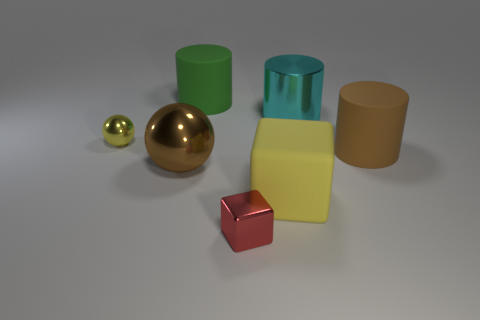What color is the thing that is both in front of the brown metallic ball and left of the big yellow thing?
Give a very brief answer. Red. Is there a small blue rubber thing of the same shape as the yellow metal thing?
Provide a short and direct response. No. What is the material of the big cyan cylinder?
Give a very brief answer. Metal. There is a yellow metallic object; are there any large cyan objects in front of it?
Your answer should be very brief. No. Do the brown metal thing and the tiny yellow metallic object have the same shape?
Keep it short and to the point. Yes. How many other objects are there of the same size as the cyan shiny cylinder?
Make the answer very short. 4. How many things are large brown things that are to the right of the green rubber cylinder or rubber things?
Offer a very short reply. 3. What color is the big shiny cylinder?
Offer a terse response. Cyan. There is a brown thing left of the large yellow object; what is its material?
Ensure brevity in your answer.  Metal. There is a yellow shiny thing; does it have the same shape as the big brown object in front of the big brown matte cylinder?
Your response must be concise. Yes. 